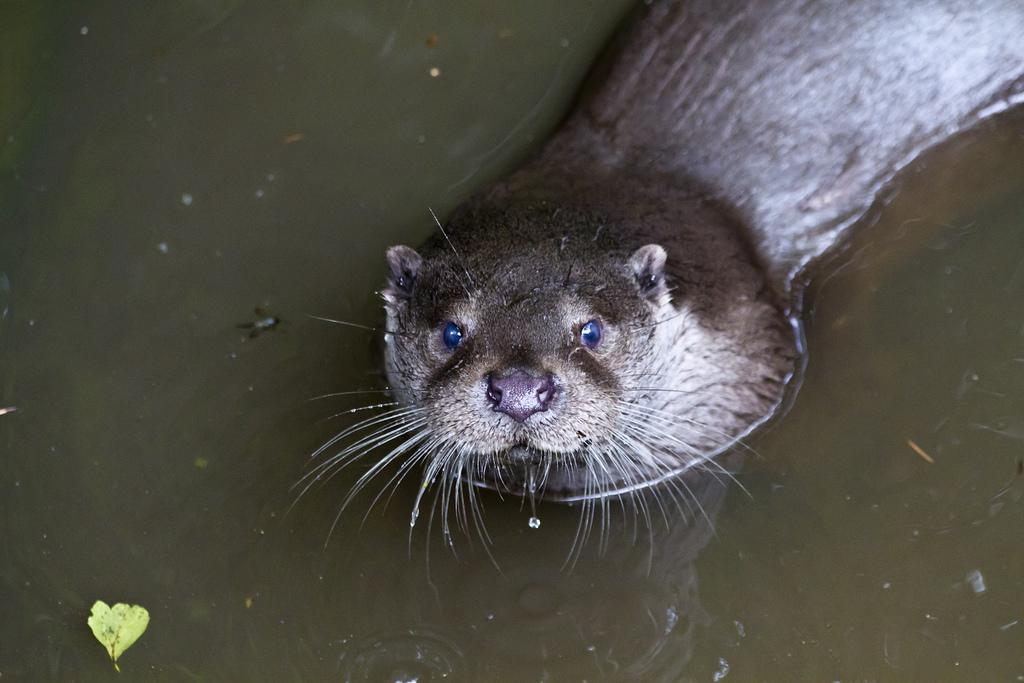What animal can be seen in the picture? There is a seal in the picture. What is visible in the background of the picture? Water is visible in the background of the picture. Can you describe the possible location of the water? The water might be in a pond. What object is located at the bottom of the picture? There is a leaf at the bottom of the picture. What color is the police officer's eye in the image? There is no police officer or eye present in the image; it features a seal and water in the background. 